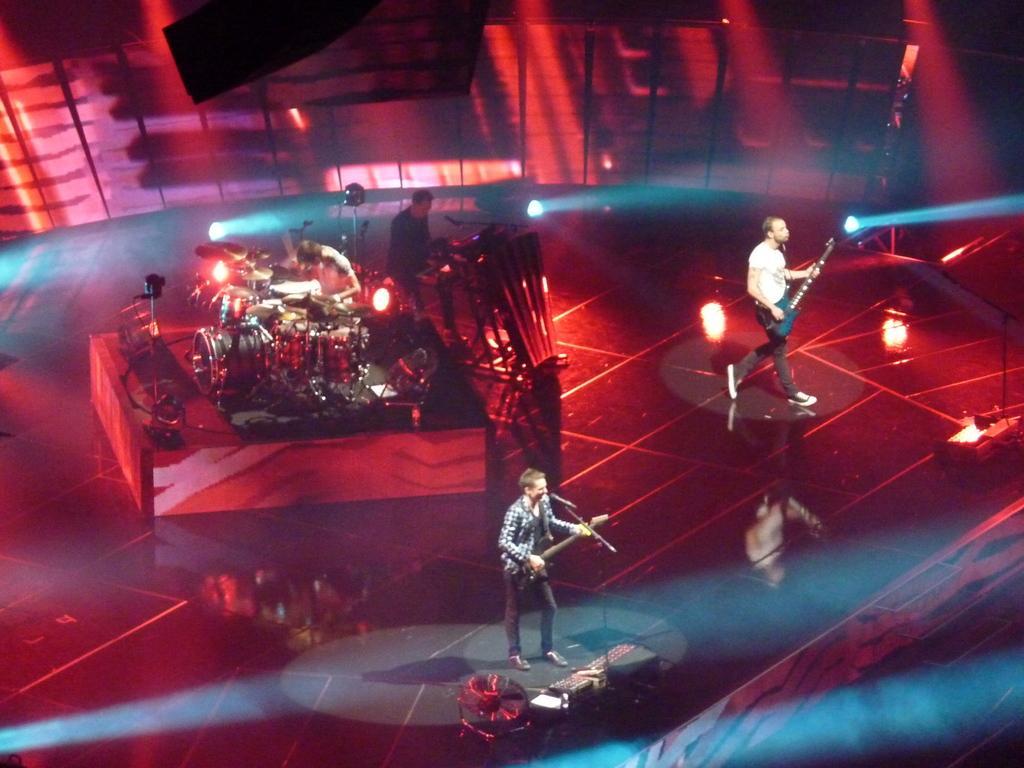Can you describe this image briefly? In the picture I can see two persons playing guitar and there are two other persons playing musical instruments behind them and the background is in red color. 